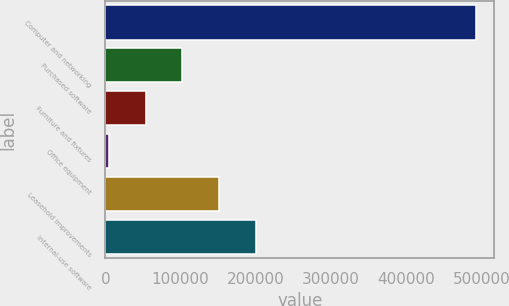Convert chart to OTSL. <chart><loc_0><loc_0><loc_500><loc_500><bar_chart><fcel>Computer and networking<fcel>Purchased software<fcel>Furniture and fixtures<fcel>Office equipment<fcel>Leasehold improvements<fcel>Internal-use software<nl><fcel>492685<fcel>102371<fcel>53581.3<fcel>4792<fcel>151160<fcel>199949<nl></chart> 